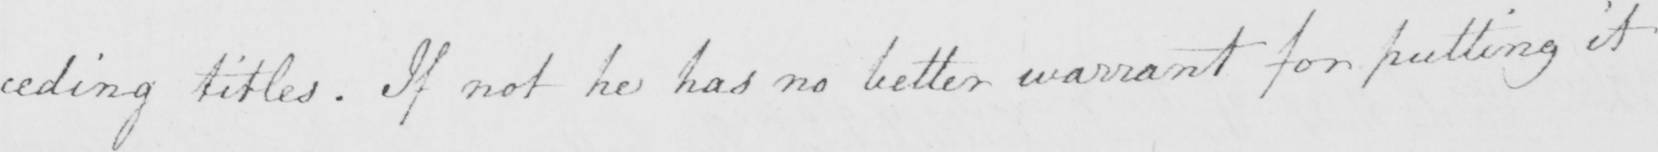Can you tell me what this handwritten text says? : ceding titles . If not he has no better warrant for putting it 